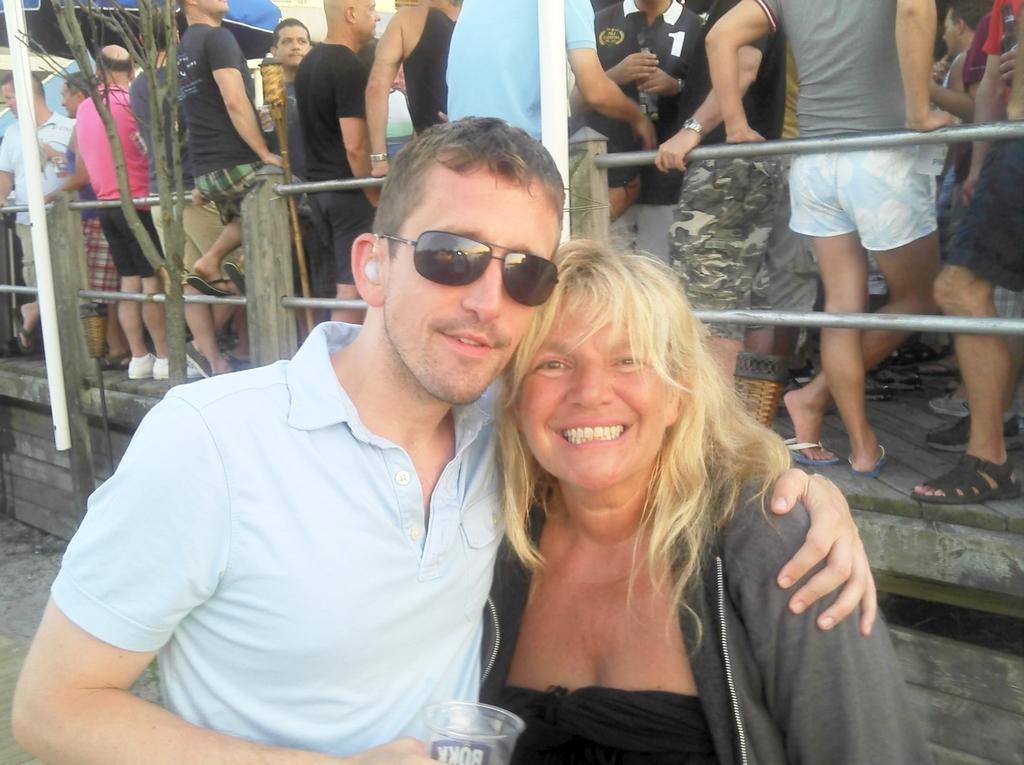How would you summarize this image in a sentence or two? In this picture we can see a man and woman are smiling in the front, there are some people standing in the background, we can see metal rods and a tree in the middle. 